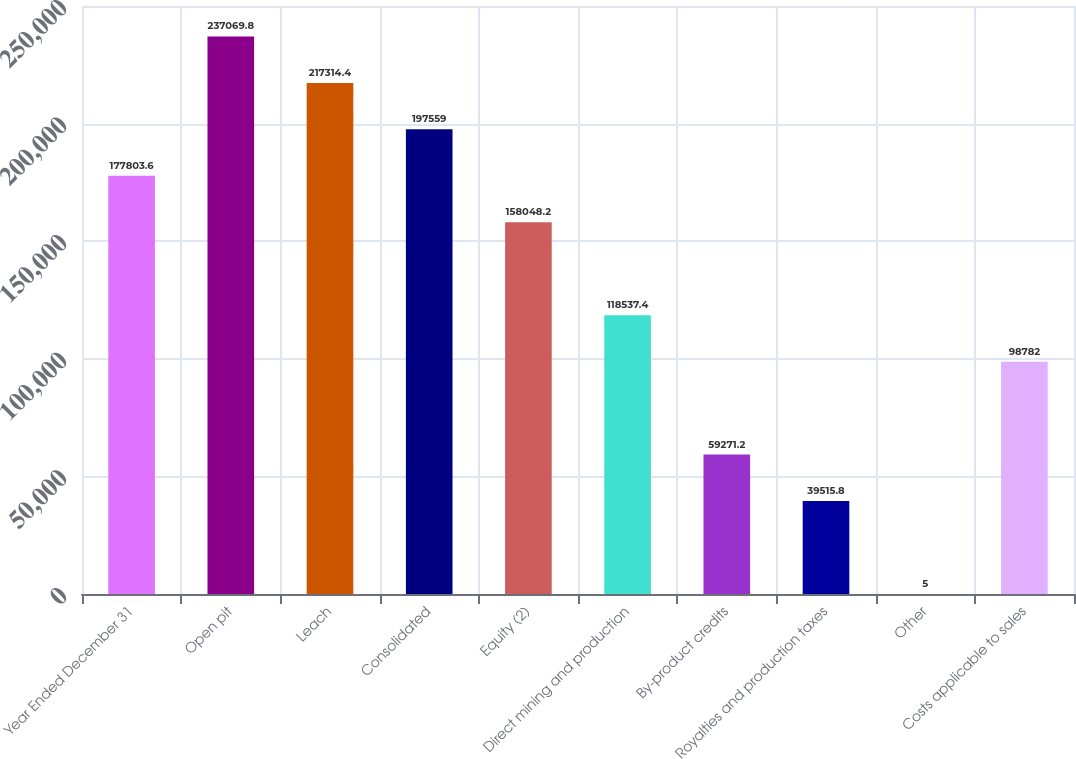<chart> <loc_0><loc_0><loc_500><loc_500><bar_chart><fcel>Year Ended December 31<fcel>Open pit<fcel>Leach<fcel>Consolidated<fcel>Equity (2)<fcel>Direct mining and production<fcel>By-product credits<fcel>Royalties and production taxes<fcel>Other<fcel>Costs applicable to sales<nl><fcel>177804<fcel>237070<fcel>217314<fcel>197559<fcel>158048<fcel>118537<fcel>59271.2<fcel>39515.8<fcel>5<fcel>98782<nl></chart> 